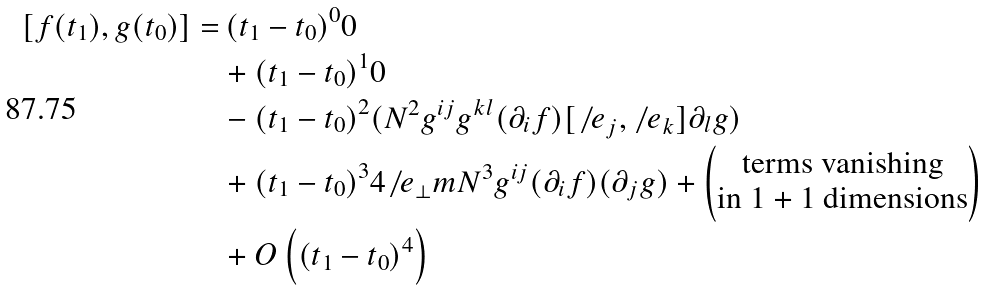Convert formula to latex. <formula><loc_0><loc_0><loc_500><loc_500>[ f ( { t } _ { 1 } ) , g ( { t } _ { 0 } ) ] = & \, { ( { t } _ { 1 } - { t } _ { 0 } ) } ^ { 0 } 0 \\ & + { ( { t } _ { 1 } - { t } _ { 0 } ) } ^ { 1 } 0 \\ & - { ( { t } _ { 1 } - { t } _ { 0 } ) } ^ { 2 } ( { N } ^ { 2 } { g } ^ { i j } { g } ^ { k l } ( { \partial } _ { i } f ) [ { \not \, e } _ { j } , { \not \, e } _ { k } ] { \partial } _ { l } g ) \\ & + { ( { t } _ { 1 } - { t } _ { 0 } ) } ^ { 3 } 4 { \not \, e } _ { \bot } m { N } ^ { 3 } { g } ^ { i j } ( { \partial } _ { i } f ) ( { \partial } _ { j } g ) + \begin{pmatrix} \text {terms vanishing} \\ \text {in $1+1$ dimensions} \end{pmatrix} \\ & + O \left ( { ( { t } _ { 1 } - { t } _ { 0 } ) } ^ { 4 } \right )</formula> 